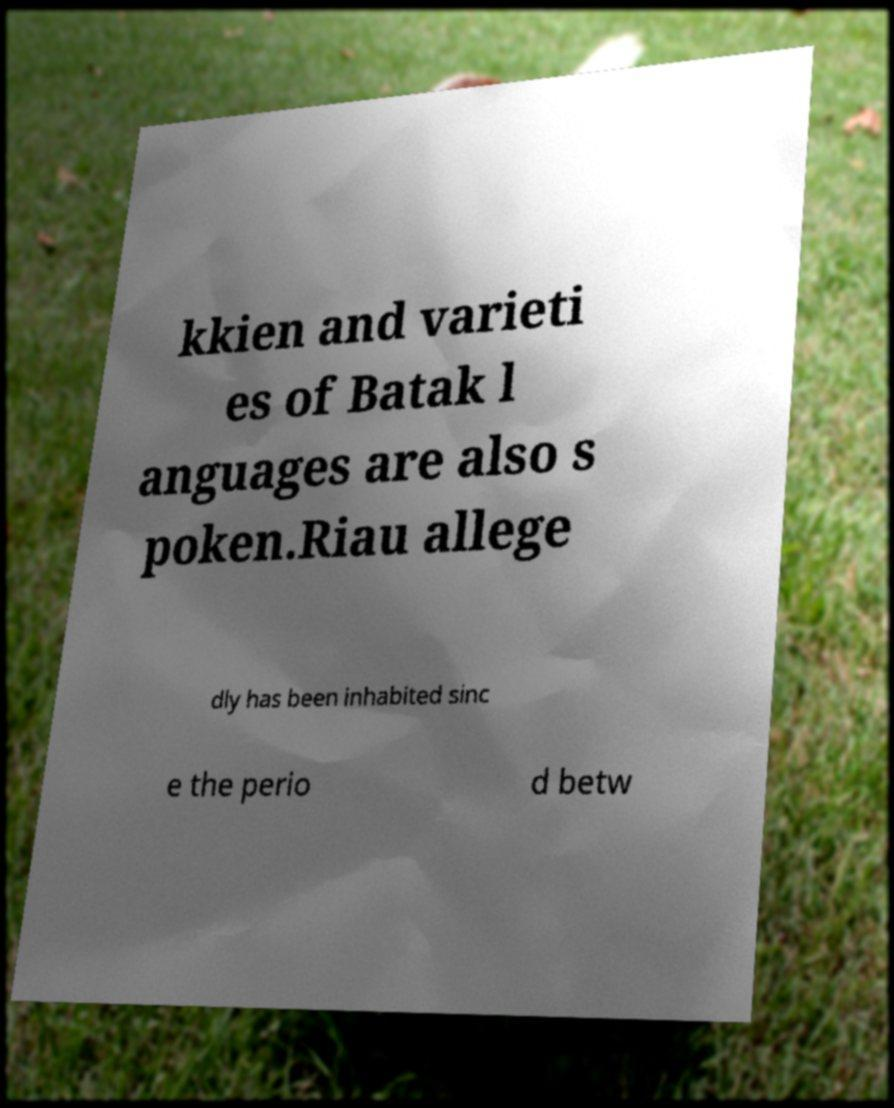There's text embedded in this image that I need extracted. Can you transcribe it verbatim? kkien and varieti es of Batak l anguages are also s poken.Riau allege dly has been inhabited sinc e the perio d betw 